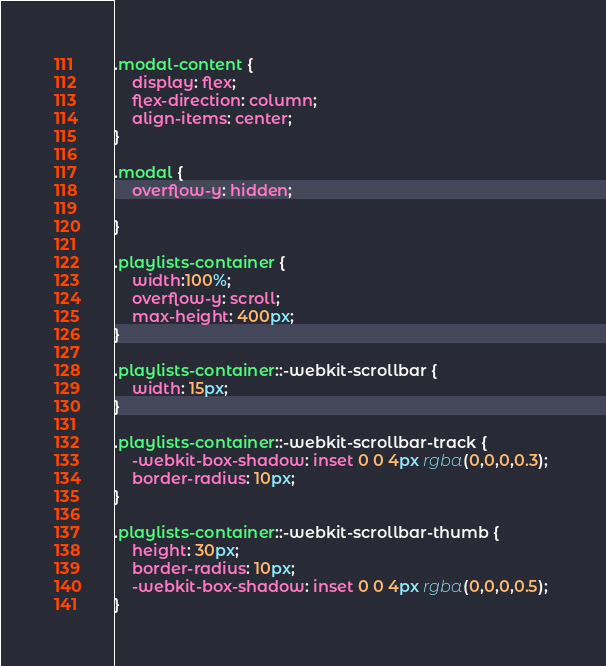<code> <loc_0><loc_0><loc_500><loc_500><_CSS_>.modal-content {
    display: flex;
    flex-direction: column;
    align-items: center;
}

.modal {
    overflow-y: hidden;
    
}

.playlists-container {
    width:100%;
    overflow-y: scroll;
    max-height: 400px;
}

.playlists-container::-webkit-scrollbar {
    width: 15px;
}
 
.playlists-container::-webkit-scrollbar-track {
    -webkit-box-shadow: inset 0 0 4px rgba(0,0,0,0.3); 
    border-radius: 10px;
}
 
.playlists-container::-webkit-scrollbar-thumb {   
    height: 30px;
    border-radius: 10px;
    -webkit-box-shadow: inset 0 0 4px rgba(0,0,0,0.5); 
}</code> 